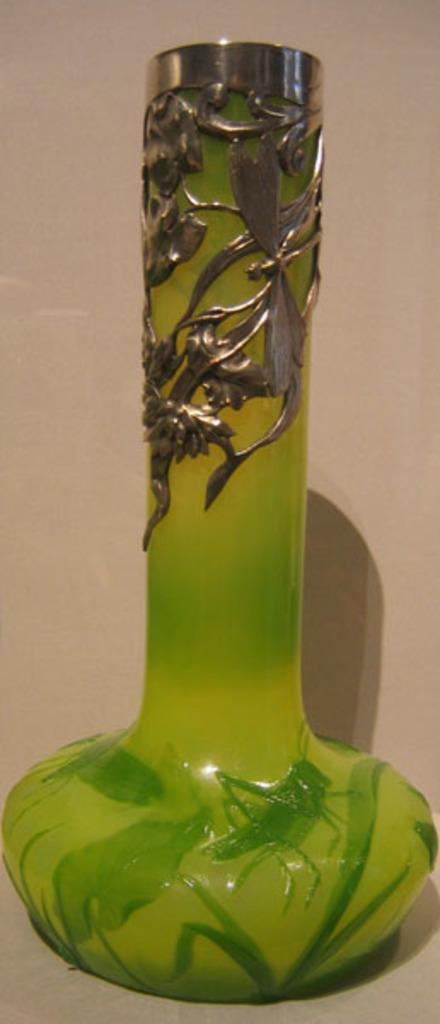How would you summarize this image in a sentence or two? In this picture we can see a glass bottle on a platform. 